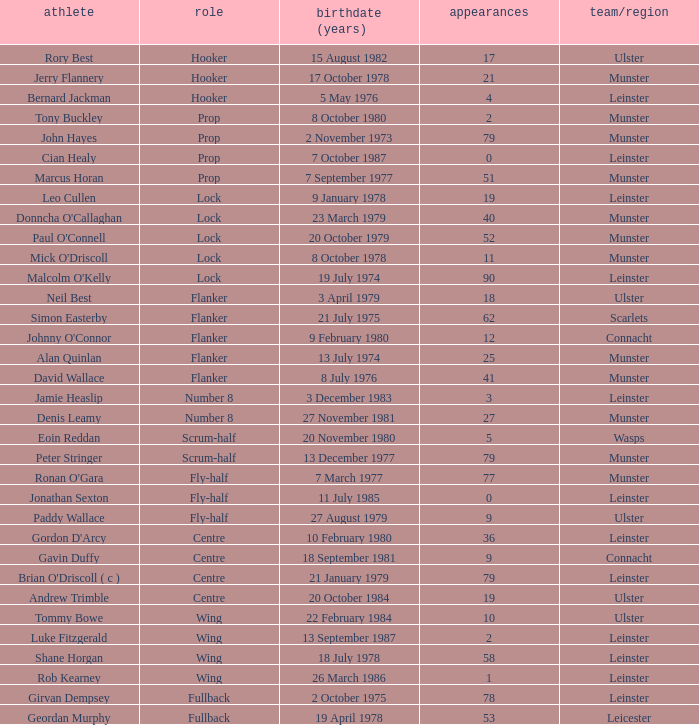How many Caps does the Club/province Munster, position of lock and Mick O'Driscoll have? 1.0. 